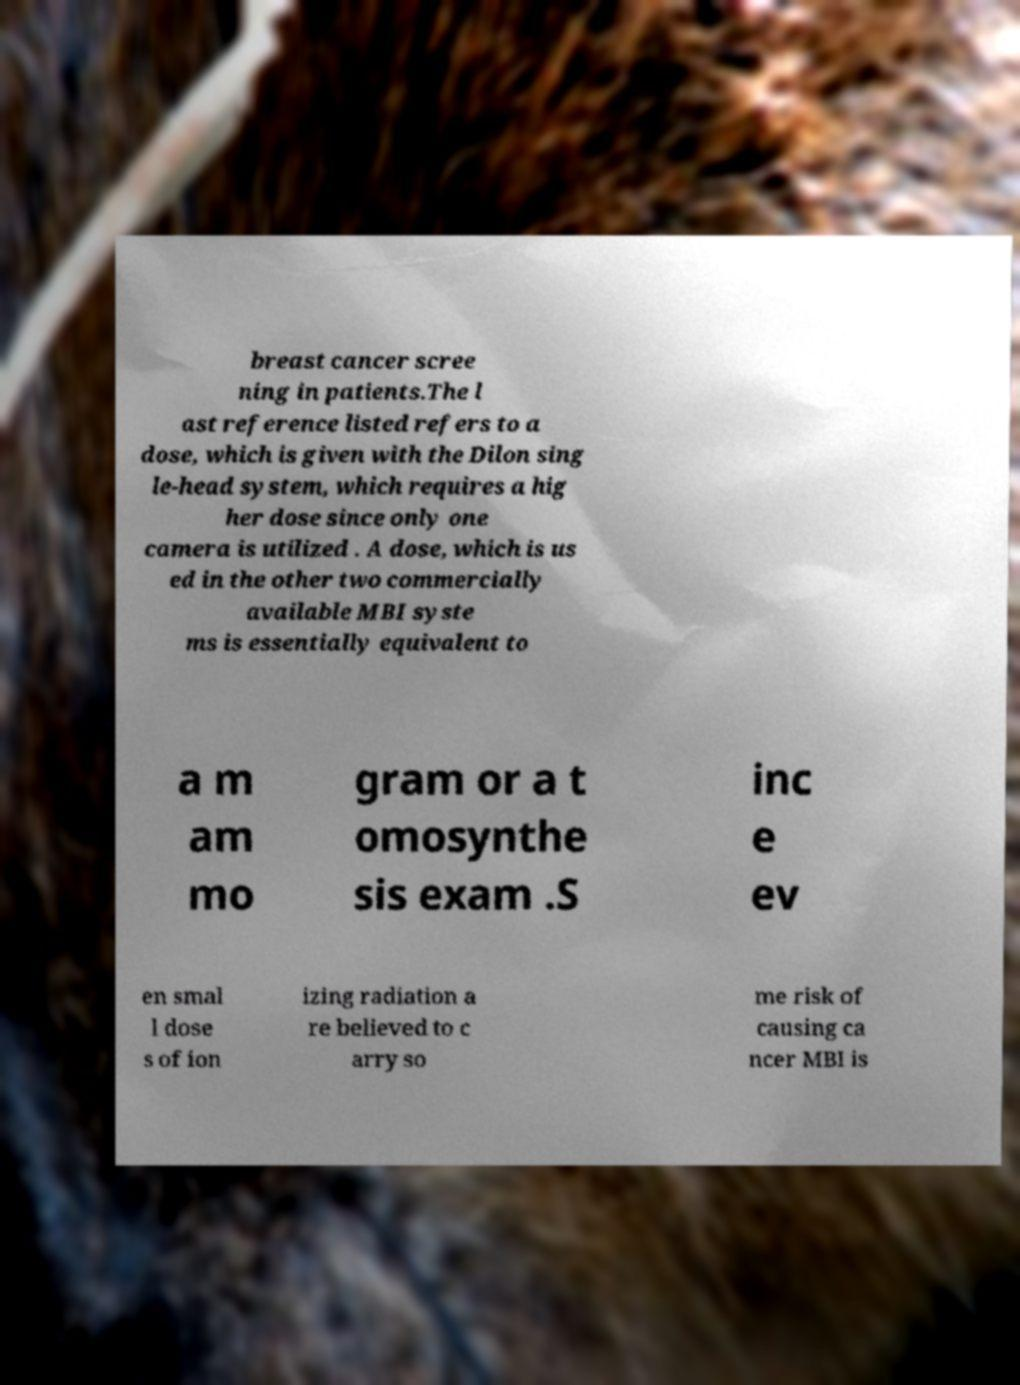Can you read and provide the text displayed in the image?This photo seems to have some interesting text. Can you extract and type it out for me? breast cancer scree ning in patients.The l ast reference listed refers to a dose, which is given with the Dilon sing le-head system, which requires a hig her dose since only one camera is utilized . A dose, which is us ed in the other two commercially available MBI syste ms is essentially equivalent to a m am mo gram or a t omosynthe sis exam .S inc e ev en smal l dose s of ion izing radiation a re believed to c arry so me risk of causing ca ncer MBI is 